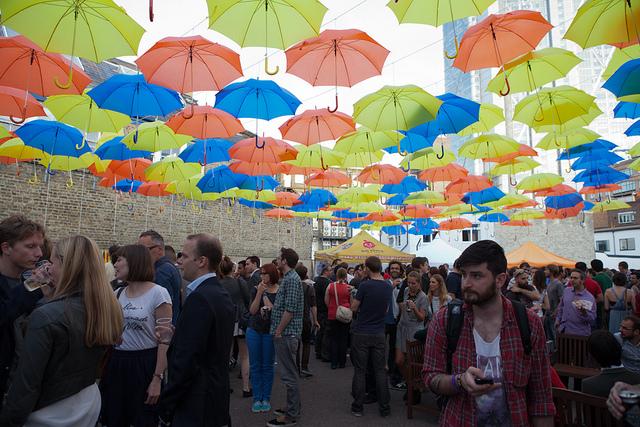How do the umbrellas stay in the air?
Be succinct. Wires. Are the umbrellas the same color?
Write a very short answer. No. What is in the sky?
Quick response, please. Umbrellas. How many umbrellas are in the photo?
Write a very short answer. 40. Why are there so many people in this picture?
Concise answer only. Festival. What pattern is repeated?
Write a very short answer. Umbrellas. What culture is likely represented based on the items for sale on the wall?
Answer briefly. Chinese. 